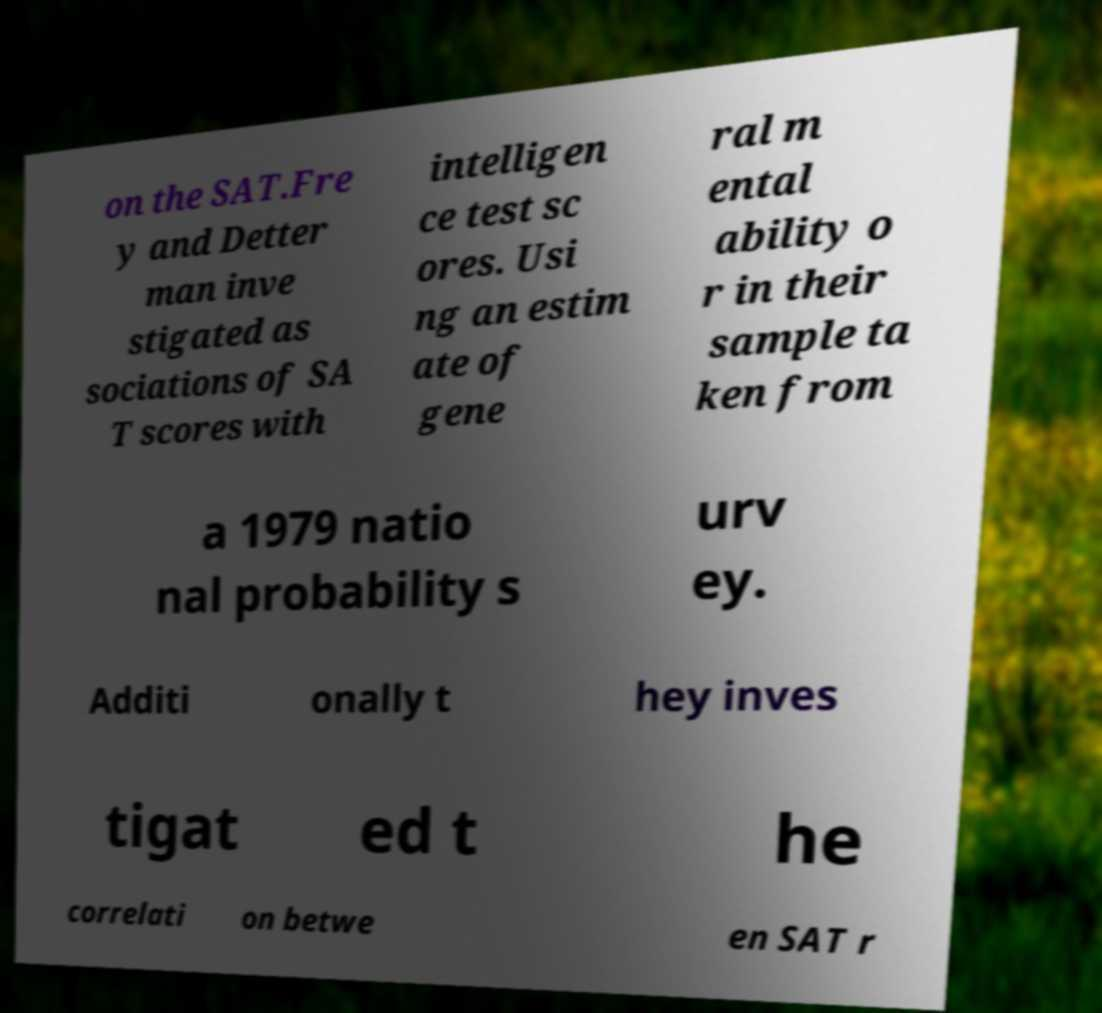Could you extract and type out the text from this image? on the SAT.Fre y and Detter man inve stigated as sociations of SA T scores with intelligen ce test sc ores. Usi ng an estim ate of gene ral m ental ability o r in their sample ta ken from a 1979 natio nal probability s urv ey. Additi onally t hey inves tigat ed t he correlati on betwe en SAT r 